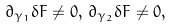<formula> <loc_0><loc_0><loc_500><loc_500>\partial _ { \gamma _ { 1 } } \delta { F } \neq 0 , \, \partial _ { \gamma _ { 2 } } \delta { F } \neq 0 ,</formula> 